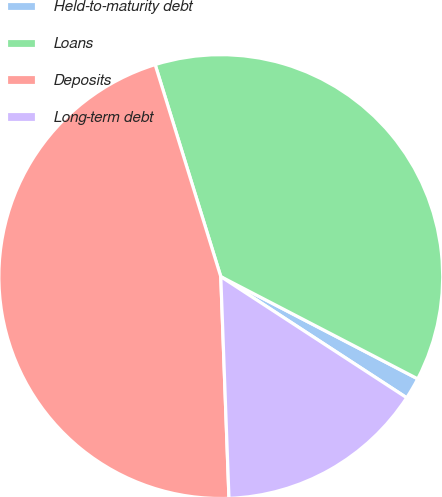Convert chart to OTSL. <chart><loc_0><loc_0><loc_500><loc_500><pie_chart><fcel>Held-to-maturity debt<fcel>Loans<fcel>Deposits<fcel>Long-term debt<nl><fcel>1.57%<fcel>37.4%<fcel>45.81%<fcel>15.22%<nl></chart> 